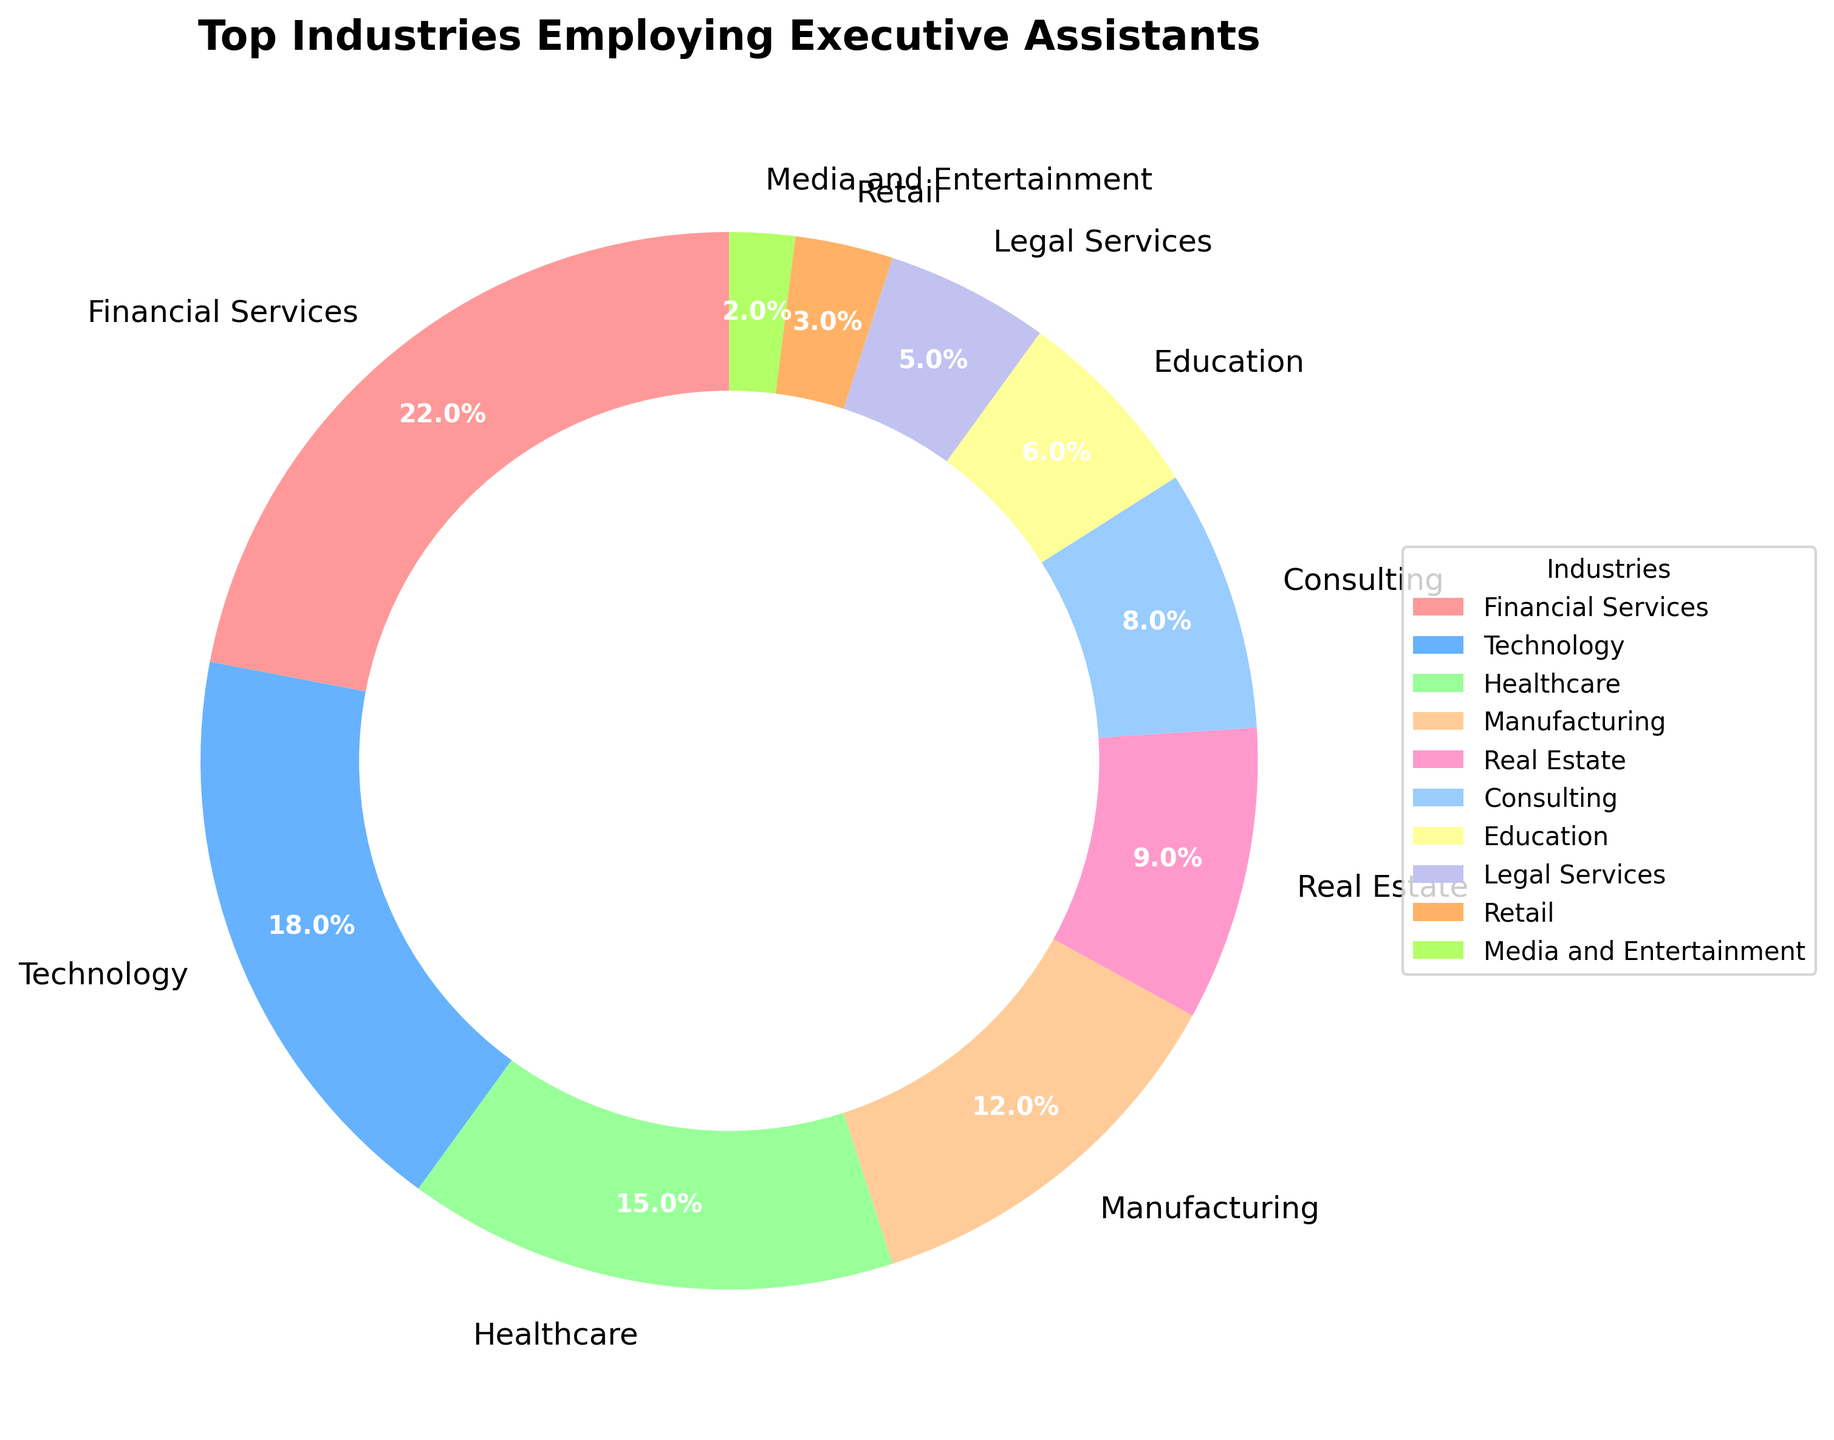What percentage of executive assistants are employed in the Technology and Healthcare industries combined? Add the percentages of the Technology and Healthcare industries (18% and 15%, respectively). The sum is 18 + 15 = 33%.
Answer: 33% Which industry employs the highest percentage of executive assistants? The Financial Services sector has the highest percentage at 22%, as seen from the pie chart.
Answer: Financial Services Compare the employment percentages between Consulting and Real Estate industries. Which one employs more executive assistants? Consulting employs 8%, and Real Estate employs 9%. Real Estate has a higher percentage.
Answer: Real Estate What is the difference in employment percentages between the Manufacturing and Retail industries? Subtract the percentage of Retail (3%) from Manufacturing (12%). The difference is 12 - 3 = 9%.
Answer: 9% How many industries employ less than 10% of executive assistants? Review the chart and count: Real Estate (9%), Consulting (8%), Education (6%), Legal Services (5%), Retail (3%), Media and Entertainment (2%) are all below 10%. There are 6 industries.
Answer: 6 What is the average employment percentage of executive assistants in the Financial Services, Technology, and Healthcare industries? Add the percentages (22 + 18 + 15 = 55) and divide by the number of industries (3). The average is 55 / 3 ≈ 18.33%.
Answer: 18.33% Which industry employs the least percentage of executive assistants and what is that percentage? Media and Entertainment employs the least at 2%, as indicated on the pie chart.
Answer: Media and Entertainment, 2% Is the sum of the percentages of the Technology and Consulting industries greater than that of the Financial Services industry? Technology has 18% and Consulting has 8%. Their sum is 18 + 8 = 26%, which is greater than Financial Services at 22%.
Answer: Yes What percentage more does the Financial Services industry employ executive assistants compared to the Legal Services industry? Subtract the percentage of Legal Services (5%) from Financial Services (22%). The percentage difference is 22 - 5 = 17%.
Answer: 17% 